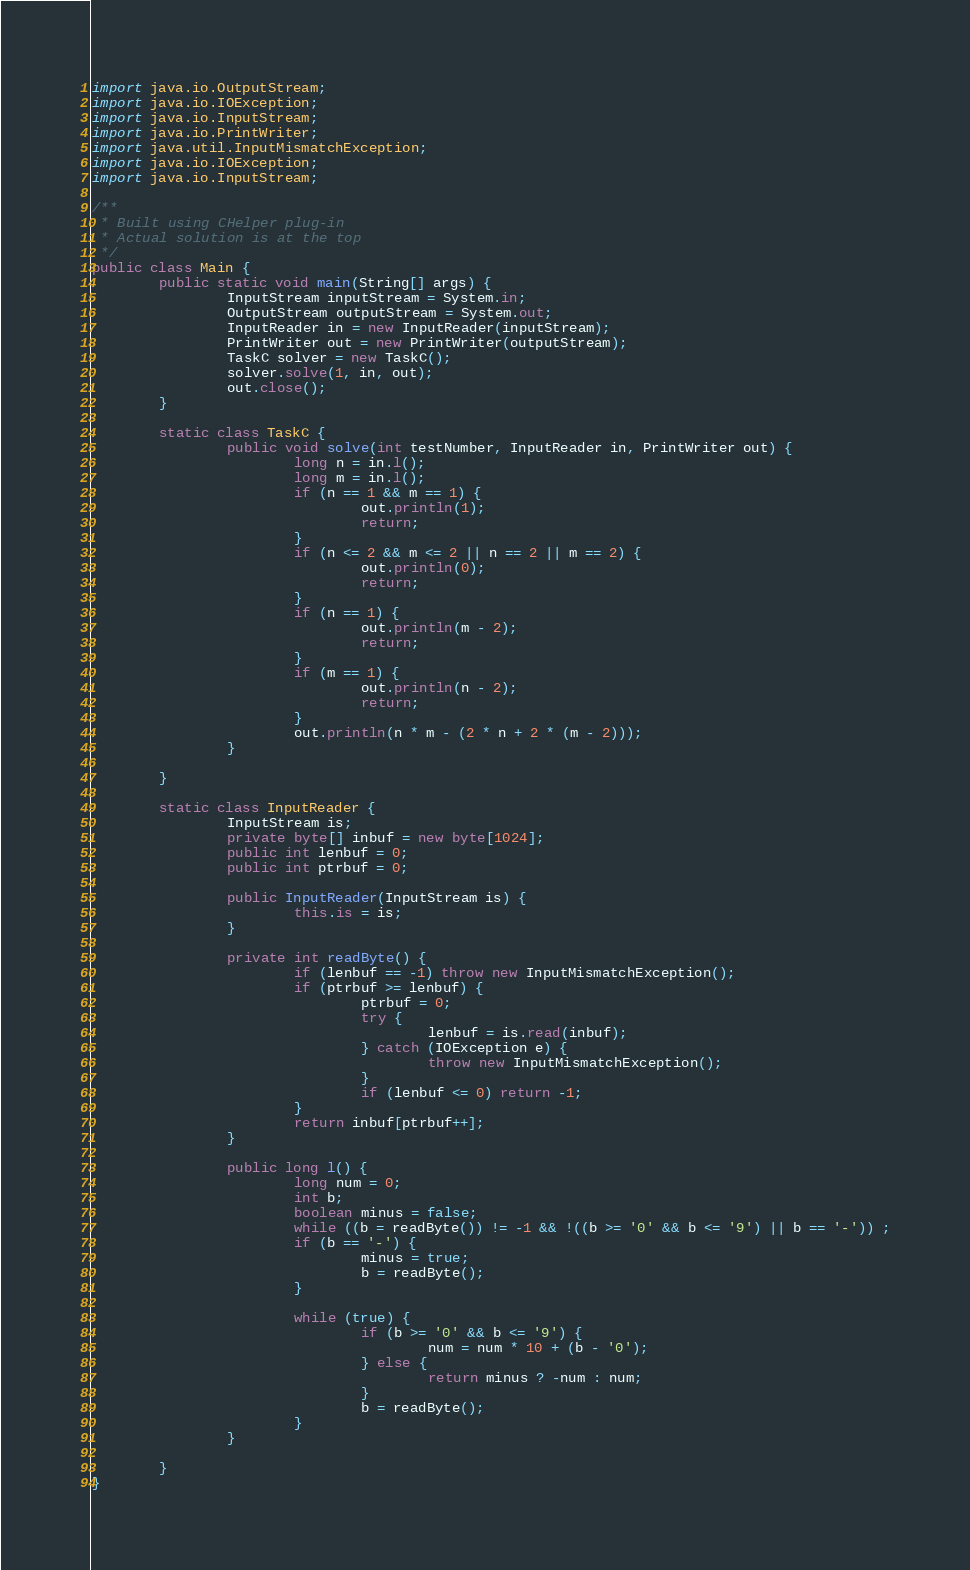<code> <loc_0><loc_0><loc_500><loc_500><_Java_>import java.io.OutputStream;
import java.io.IOException;
import java.io.InputStream;
import java.io.PrintWriter;
import java.util.InputMismatchException;
import java.io.IOException;
import java.io.InputStream;

/**
 * Built using CHelper plug-in
 * Actual solution is at the top
 */
public class Main {
        public static void main(String[] args) {
                InputStream inputStream = System.in;
                OutputStream outputStream = System.out;
                InputReader in = new InputReader(inputStream);
                PrintWriter out = new PrintWriter(outputStream);
                TaskC solver = new TaskC();
                solver.solve(1, in, out);
                out.close();
        }

        static class TaskC {
                public void solve(int testNumber, InputReader in, PrintWriter out) {
                        long n = in.l();
                        long m = in.l();
                        if (n == 1 && m == 1) {
                                out.println(1);
                                return;
                        }
                        if (n <= 2 && m <= 2 || n == 2 || m == 2) {
                                out.println(0);
                                return;
                        }
                        if (n == 1) {
                                out.println(m - 2);
                                return;
                        }
                        if (m == 1) {
                                out.println(n - 2);
                                return;
                        }
                        out.println(n * m - (2 * n + 2 * (m - 2)));
                }

        }

        static class InputReader {
                InputStream is;
                private byte[] inbuf = new byte[1024];
                public int lenbuf = 0;
                public int ptrbuf = 0;

                public InputReader(InputStream is) {
                        this.is = is;
                }

                private int readByte() {
                        if (lenbuf == -1) throw new InputMismatchException();
                        if (ptrbuf >= lenbuf) {
                                ptrbuf = 0;
                                try {
                                        lenbuf = is.read(inbuf);
                                } catch (IOException e) {
                                        throw new InputMismatchException();
                                }
                                if (lenbuf <= 0) return -1;
                        }
                        return inbuf[ptrbuf++];
                }

                public long l() {
                        long num = 0;
                        int b;
                        boolean minus = false;
                        while ((b = readByte()) != -1 && !((b >= '0' && b <= '9') || b == '-')) ;
                        if (b == '-') {
                                minus = true;
                                b = readByte();
                        }

                        while (true) {
                                if (b >= '0' && b <= '9') {
                                        num = num * 10 + (b - '0');
                                } else {
                                        return minus ? -num : num;
                                }
                                b = readByte();
                        }
                }

        }
}

</code> 